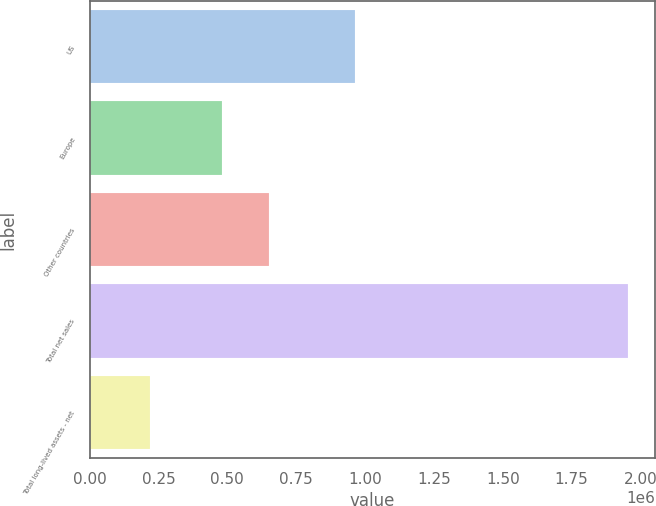Convert chart to OTSL. <chart><loc_0><loc_0><loc_500><loc_500><bar_chart><fcel>US<fcel>Europe<fcel>Other countries<fcel>Total net sales<fcel>Total long-lived assets - net<nl><fcel>963137<fcel>479744<fcel>653254<fcel>1.95426e+06<fcel>219161<nl></chart> 